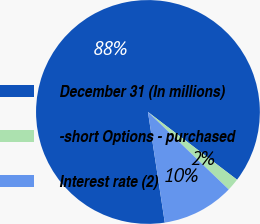<chart> <loc_0><loc_0><loc_500><loc_500><pie_chart><fcel>December 31 (In millions)<fcel>-short Options - purchased<fcel>Interest rate (2)<nl><fcel>87.75%<fcel>1.83%<fcel>10.42%<nl></chart> 